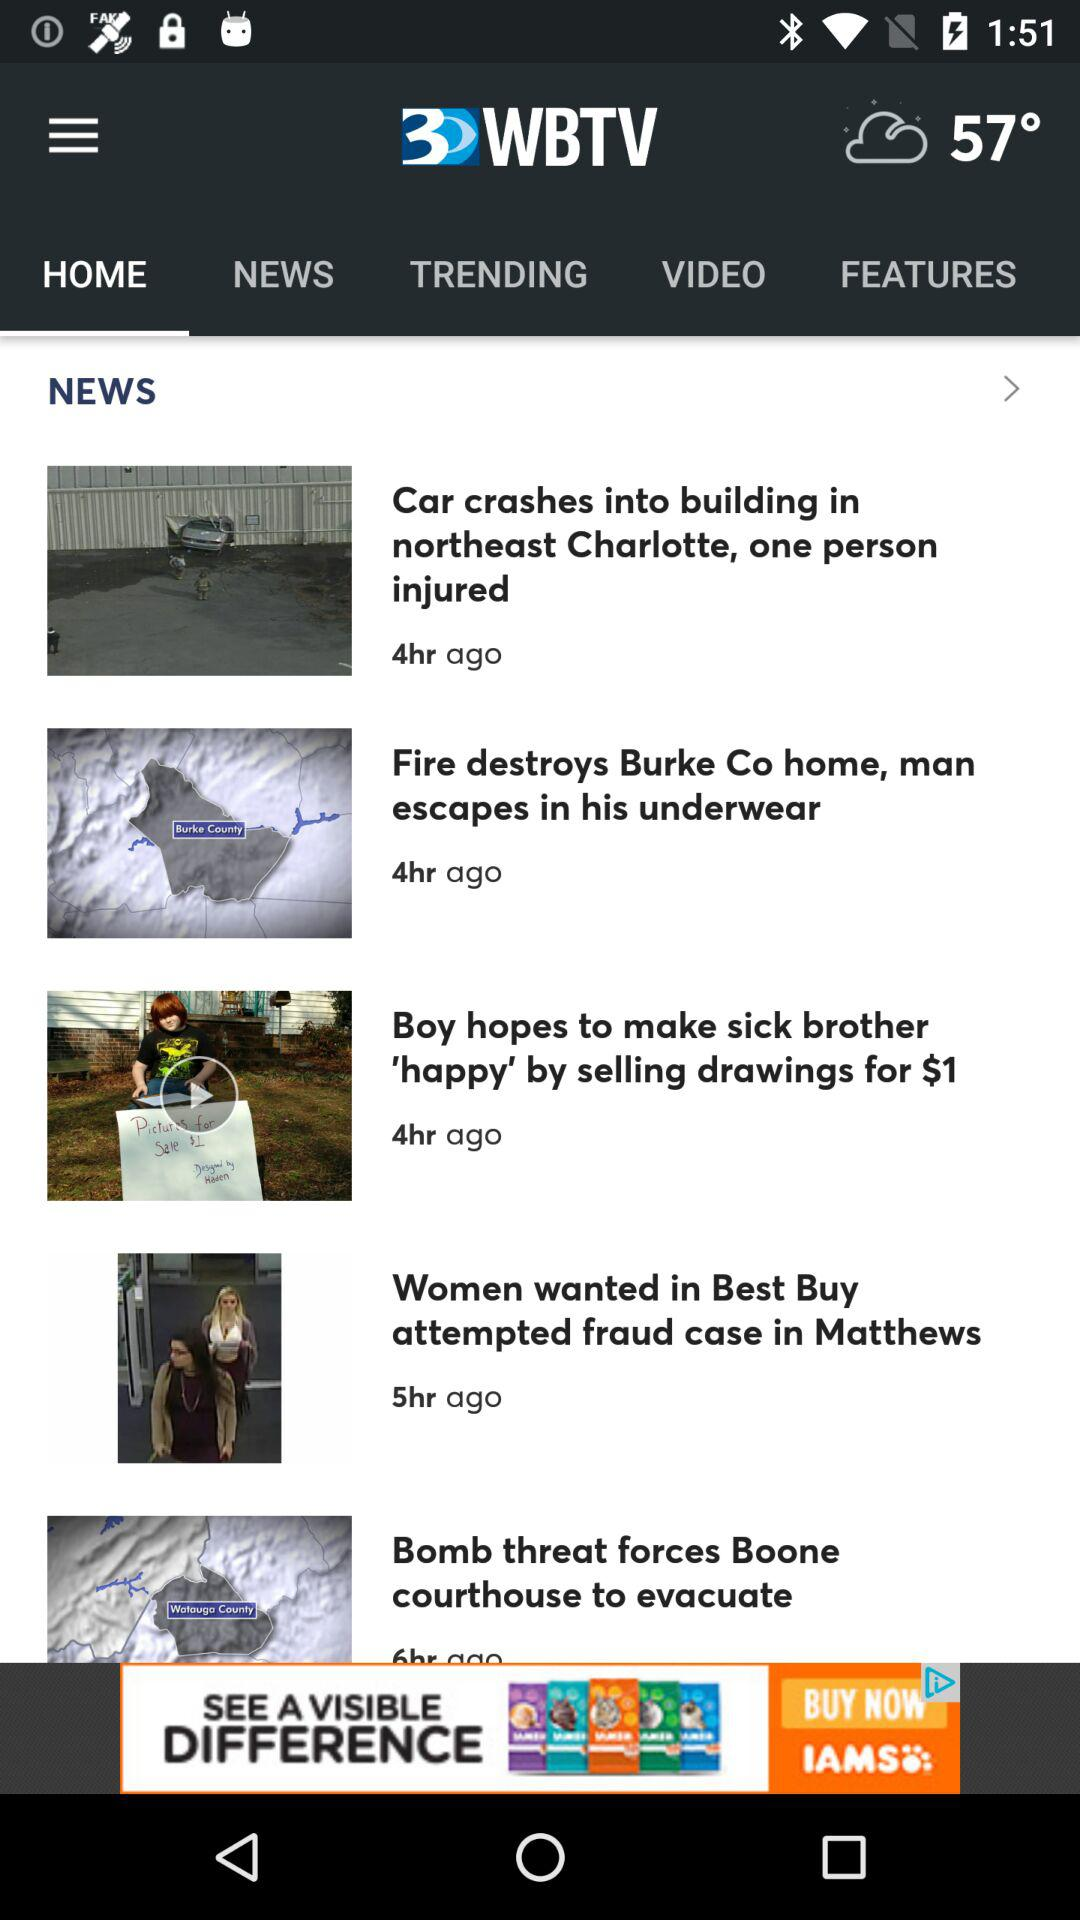Which tab is selected? The selected tab is "HOME". 